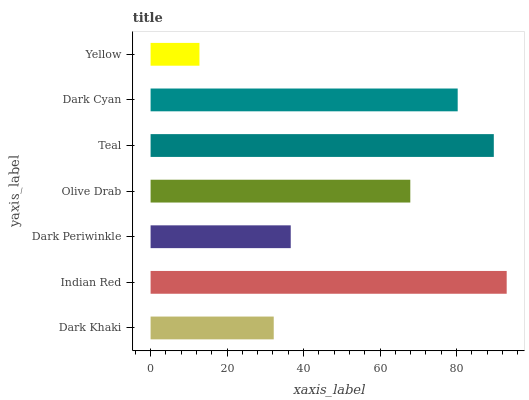Is Yellow the minimum?
Answer yes or no. Yes. Is Indian Red the maximum?
Answer yes or no. Yes. Is Dark Periwinkle the minimum?
Answer yes or no. No. Is Dark Periwinkle the maximum?
Answer yes or no. No. Is Indian Red greater than Dark Periwinkle?
Answer yes or no. Yes. Is Dark Periwinkle less than Indian Red?
Answer yes or no. Yes. Is Dark Periwinkle greater than Indian Red?
Answer yes or no. No. Is Indian Red less than Dark Periwinkle?
Answer yes or no. No. Is Olive Drab the high median?
Answer yes or no. Yes. Is Olive Drab the low median?
Answer yes or no. Yes. Is Teal the high median?
Answer yes or no. No. Is Dark Khaki the low median?
Answer yes or no. No. 